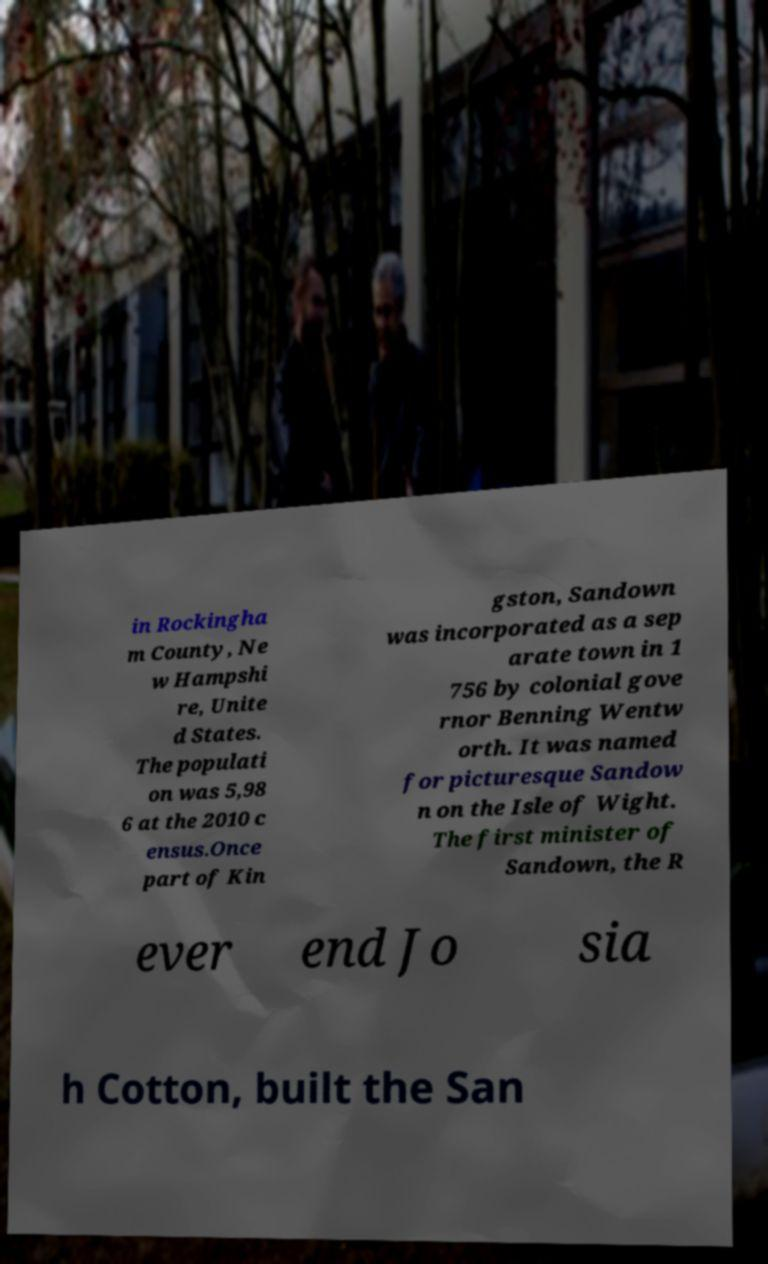Can you read and provide the text displayed in the image?This photo seems to have some interesting text. Can you extract and type it out for me? in Rockingha m County, Ne w Hampshi re, Unite d States. The populati on was 5,98 6 at the 2010 c ensus.Once part of Kin gston, Sandown was incorporated as a sep arate town in 1 756 by colonial gove rnor Benning Wentw orth. It was named for picturesque Sandow n on the Isle of Wight. The first minister of Sandown, the R ever end Jo sia h Cotton, built the San 